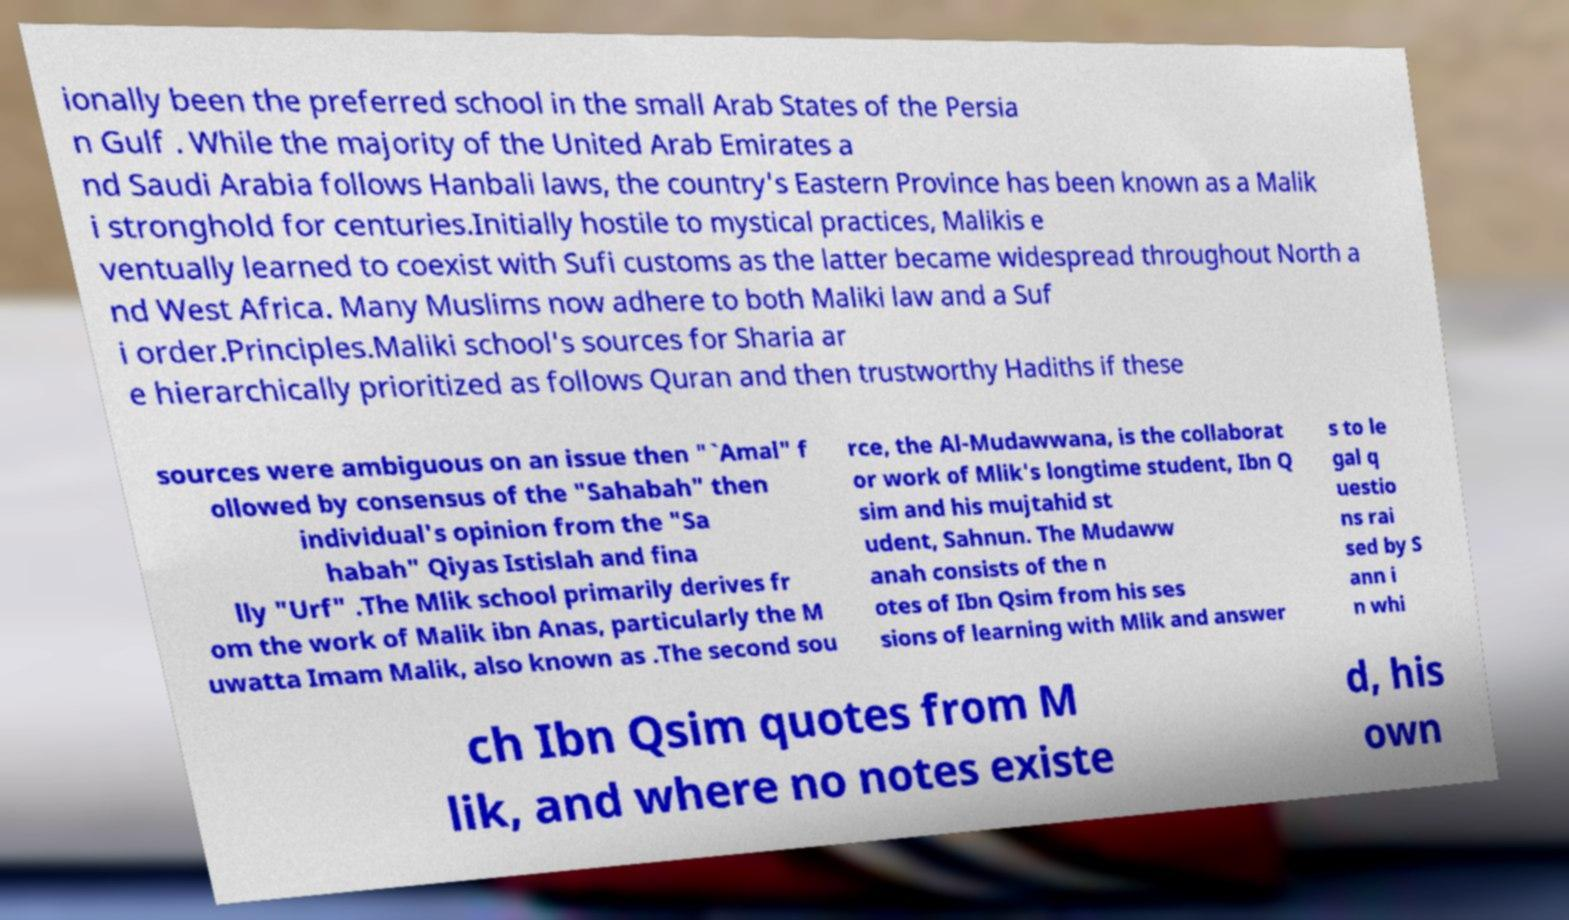What messages or text are displayed in this image? I need them in a readable, typed format. ionally been the preferred school in the small Arab States of the Persia n Gulf . While the majority of the United Arab Emirates a nd Saudi Arabia follows Hanbali laws, the country's Eastern Province has been known as a Malik i stronghold for centuries.Initially hostile to mystical practices, Malikis e ventually learned to coexist with Sufi customs as the latter became widespread throughout North a nd West Africa. Many Muslims now adhere to both Maliki law and a Suf i order.Principles.Maliki school's sources for Sharia ar e hierarchically prioritized as follows Quran and then trustworthy Hadiths if these sources were ambiguous on an issue then "`Amal" f ollowed by consensus of the "Sahabah" then individual's opinion from the "Sa habah" Qiyas Istislah and fina lly "Urf" .The Mlik school primarily derives fr om the work of Malik ibn Anas, particularly the M uwatta Imam Malik, also known as .The second sou rce, the Al-Mudawwana, is the collaborat or work of Mlik's longtime student, Ibn Q sim and his mujtahid st udent, Sahnun. The Mudaww anah consists of the n otes of Ibn Qsim from his ses sions of learning with Mlik and answer s to le gal q uestio ns rai sed by S ann i n whi ch Ibn Qsim quotes from M lik, and where no notes existe d, his own 